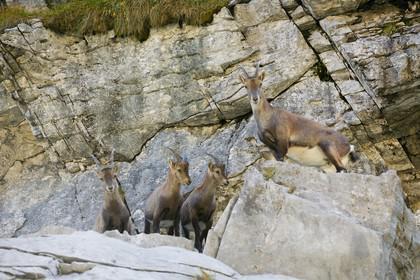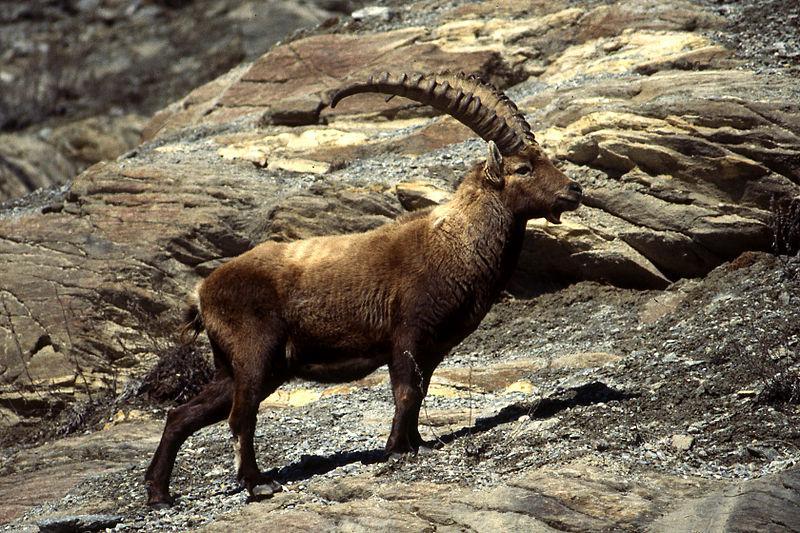The first image is the image on the left, the second image is the image on the right. For the images displayed, is the sentence "There are exactly four animals in the image on the left." factually correct? Answer yes or no. Yes. 